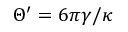Convert formula to latex. <formula><loc_0><loc_0><loc_500><loc_500>\Theta ^ { \prime } = 6 \pi \gamma / \kappa</formula> 